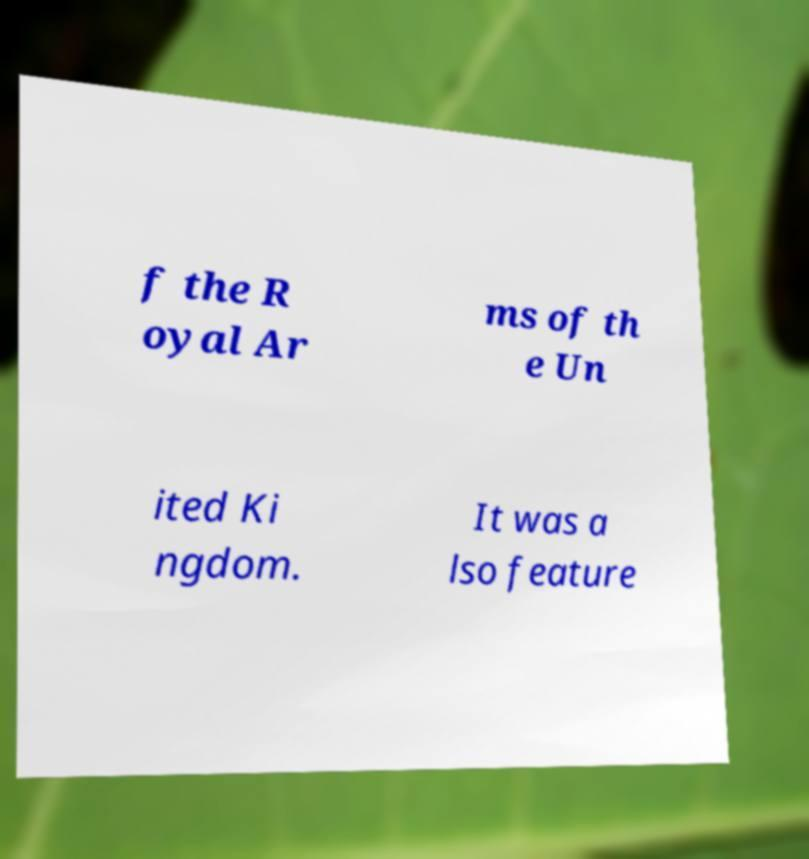What messages or text are displayed in this image? I need them in a readable, typed format. f the R oyal Ar ms of th e Un ited Ki ngdom. It was a lso feature 